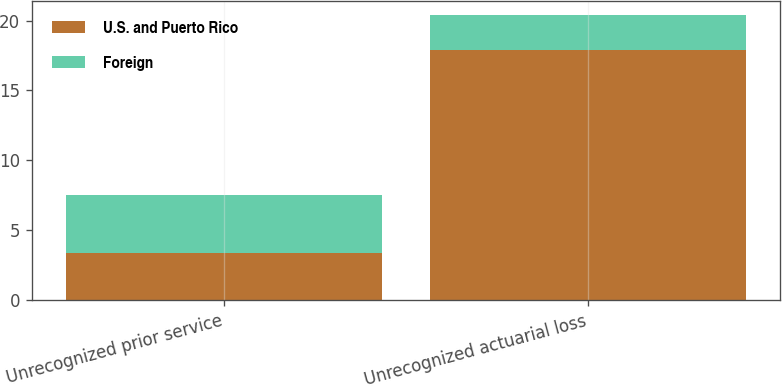<chart> <loc_0><loc_0><loc_500><loc_500><stacked_bar_chart><ecel><fcel>Unrecognized prior service<fcel>Unrecognized actuarial loss<nl><fcel>U.S. and Puerto Rico<fcel>3.4<fcel>17.9<nl><fcel>Foreign<fcel>4.1<fcel>2.5<nl></chart> 